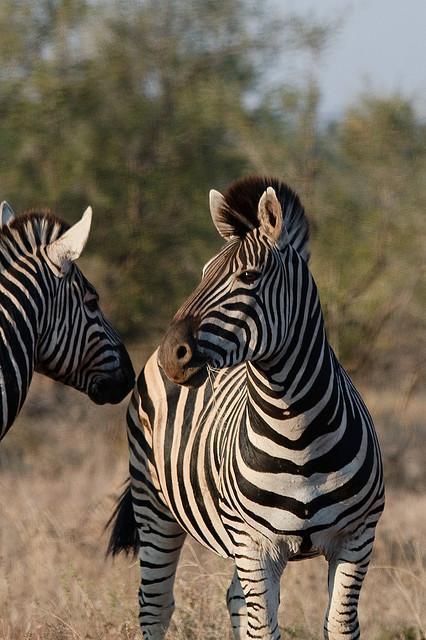How many ears are visible in the photo?
Give a very brief answer. 4. How many zebras are in the photo?
Give a very brief answer. 2. How many men are wearing a tie?
Give a very brief answer. 0. 